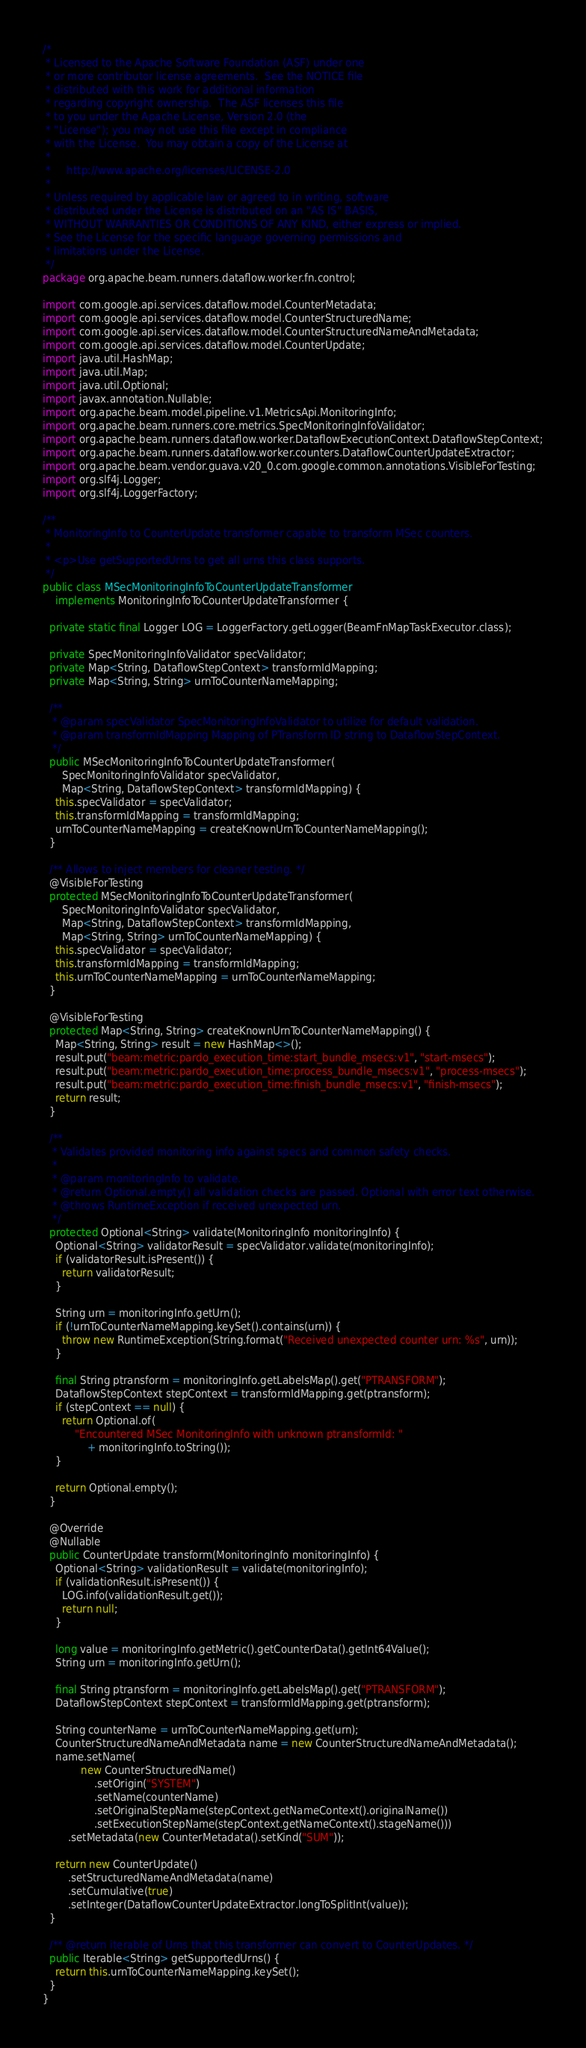<code> <loc_0><loc_0><loc_500><loc_500><_Java_>/*
 * Licensed to the Apache Software Foundation (ASF) under one
 * or more contributor license agreements.  See the NOTICE file
 * distributed with this work for additional information
 * regarding copyright ownership.  The ASF licenses this file
 * to you under the Apache License, Version 2.0 (the
 * "License"); you may not use this file except in compliance
 * with the License.  You may obtain a copy of the License at
 *
 *     http://www.apache.org/licenses/LICENSE-2.0
 *
 * Unless required by applicable law or agreed to in writing, software
 * distributed under the License is distributed on an "AS IS" BASIS,
 * WITHOUT WARRANTIES OR CONDITIONS OF ANY KIND, either express or implied.
 * See the License for the specific language governing permissions and
 * limitations under the License.
 */
package org.apache.beam.runners.dataflow.worker.fn.control;

import com.google.api.services.dataflow.model.CounterMetadata;
import com.google.api.services.dataflow.model.CounterStructuredName;
import com.google.api.services.dataflow.model.CounterStructuredNameAndMetadata;
import com.google.api.services.dataflow.model.CounterUpdate;
import java.util.HashMap;
import java.util.Map;
import java.util.Optional;
import javax.annotation.Nullable;
import org.apache.beam.model.pipeline.v1.MetricsApi.MonitoringInfo;
import org.apache.beam.runners.core.metrics.SpecMonitoringInfoValidator;
import org.apache.beam.runners.dataflow.worker.DataflowExecutionContext.DataflowStepContext;
import org.apache.beam.runners.dataflow.worker.counters.DataflowCounterUpdateExtractor;
import org.apache.beam.vendor.guava.v20_0.com.google.common.annotations.VisibleForTesting;
import org.slf4j.Logger;
import org.slf4j.LoggerFactory;

/**
 * MonitoringInfo to CounterUpdate transformer capable to transform MSec counters.
 *
 * <p>Use getSupportedUrns to get all urns this class supports.
 */
public class MSecMonitoringInfoToCounterUpdateTransformer
    implements MonitoringInfoToCounterUpdateTransformer {

  private static final Logger LOG = LoggerFactory.getLogger(BeamFnMapTaskExecutor.class);

  private SpecMonitoringInfoValidator specValidator;
  private Map<String, DataflowStepContext> transformIdMapping;
  private Map<String, String> urnToCounterNameMapping;

  /**
   * @param specValidator SpecMonitoringInfoValidator to utilize for default validation.
   * @param transformIdMapping Mapping of PTransform ID string to DataflowStepContext.
   */
  public MSecMonitoringInfoToCounterUpdateTransformer(
      SpecMonitoringInfoValidator specValidator,
      Map<String, DataflowStepContext> transformIdMapping) {
    this.specValidator = specValidator;
    this.transformIdMapping = transformIdMapping;
    urnToCounterNameMapping = createKnownUrnToCounterNameMapping();
  }

  /** Allows to inject members for cleaner testing. */
  @VisibleForTesting
  protected MSecMonitoringInfoToCounterUpdateTransformer(
      SpecMonitoringInfoValidator specValidator,
      Map<String, DataflowStepContext> transformIdMapping,
      Map<String, String> urnToCounterNameMapping) {
    this.specValidator = specValidator;
    this.transformIdMapping = transformIdMapping;
    this.urnToCounterNameMapping = urnToCounterNameMapping;
  }

  @VisibleForTesting
  protected Map<String, String> createKnownUrnToCounterNameMapping() {
    Map<String, String> result = new HashMap<>();
    result.put("beam:metric:pardo_execution_time:start_bundle_msecs:v1", "start-msecs");
    result.put("beam:metric:pardo_execution_time:process_bundle_msecs:v1", "process-msecs");
    result.put("beam:metric:pardo_execution_time:finish_bundle_msecs:v1", "finish-msecs");
    return result;
  }

  /**
   * Validates provided monitoring info against specs and common safety checks.
   *
   * @param monitoringInfo to validate.
   * @return Optional.empty() all validation checks are passed. Optional with error text otherwise.
   * @throws RuntimeException if received unexpected urn.
   */
  protected Optional<String> validate(MonitoringInfo monitoringInfo) {
    Optional<String> validatorResult = specValidator.validate(monitoringInfo);
    if (validatorResult.isPresent()) {
      return validatorResult;
    }

    String urn = monitoringInfo.getUrn();
    if (!urnToCounterNameMapping.keySet().contains(urn)) {
      throw new RuntimeException(String.format("Received unexpected counter urn: %s", urn));
    }

    final String ptransform = monitoringInfo.getLabelsMap().get("PTRANSFORM");
    DataflowStepContext stepContext = transformIdMapping.get(ptransform);
    if (stepContext == null) {
      return Optional.of(
          "Encountered MSec MonitoringInfo with unknown ptransformId: "
              + monitoringInfo.toString());
    }

    return Optional.empty();
  }

  @Override
  @Nullable
  public CounterUpdate transform(MonitoringInfo monitoringInfo) {
    Optional<String> validationResult = validate(monitoringInfo);
    if (validationResult.isPresent()) {
      LOG.info(validationResult.get());
      return null;
    }

    long value = monitoringInfo.getMetric().getCounterData().getInt64Value();
    String urn = monitoringInfo.getUrn();

    final String ptransform = monitoringInfo.getLabelsMap().get("PTRANSFORM");
    DataflowStepContext stepContext = transformIdMapping.get(ptransform);

    String counterName = urnToCounterNameMapping.get(urn);
    CounterStructuredNameAndMetadata name = new CounterStructuredNameAndMetadata();
    name.setName(
            new CounterStructuredName()
                .setOrigin("SYSTEM")
                .setName(counterName)
                .setOriginalStepName(stepContext.getNameContext().originalName())
                .setExecutionStepName(stepContext.getNameContext().stageName()))
        .setMetadata(new CounterMetadata().setKind("SUM"));

    return new CounterUpdate()
        .setStructuredNameAndMetadata(name)
        .setCumulative(true)
        .setInteger(DataflowCounterUpdateExtractor.longToSplitInt(value));
  }

  /** @return iterable of Urns that this transformer can convert to CounterUpdates. */
  public Iterable<String> getSupportedUrns() {
    return this.urnToCounterNameMapping.keySet();
  }
}
</code> 